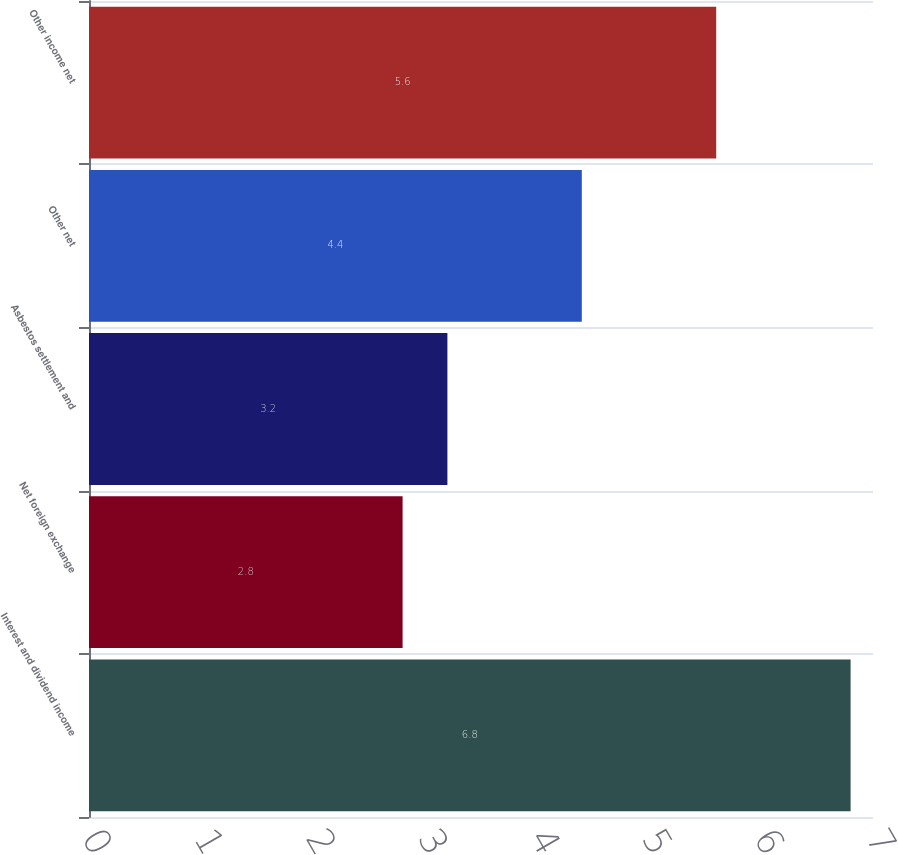<chart> <loc_0><loc_0><loc_500><loc_500><bar_chart><fcel>Interest and dividend income<fcel>Net foreign exchange<fcel>Asbestos settlement and<fcel>Other net<fcel>Other income net<nl><fcel>6.8<fcel>2.8<fcel>3.2<fcel>4.4<fcel>5.6<nl></chart> 